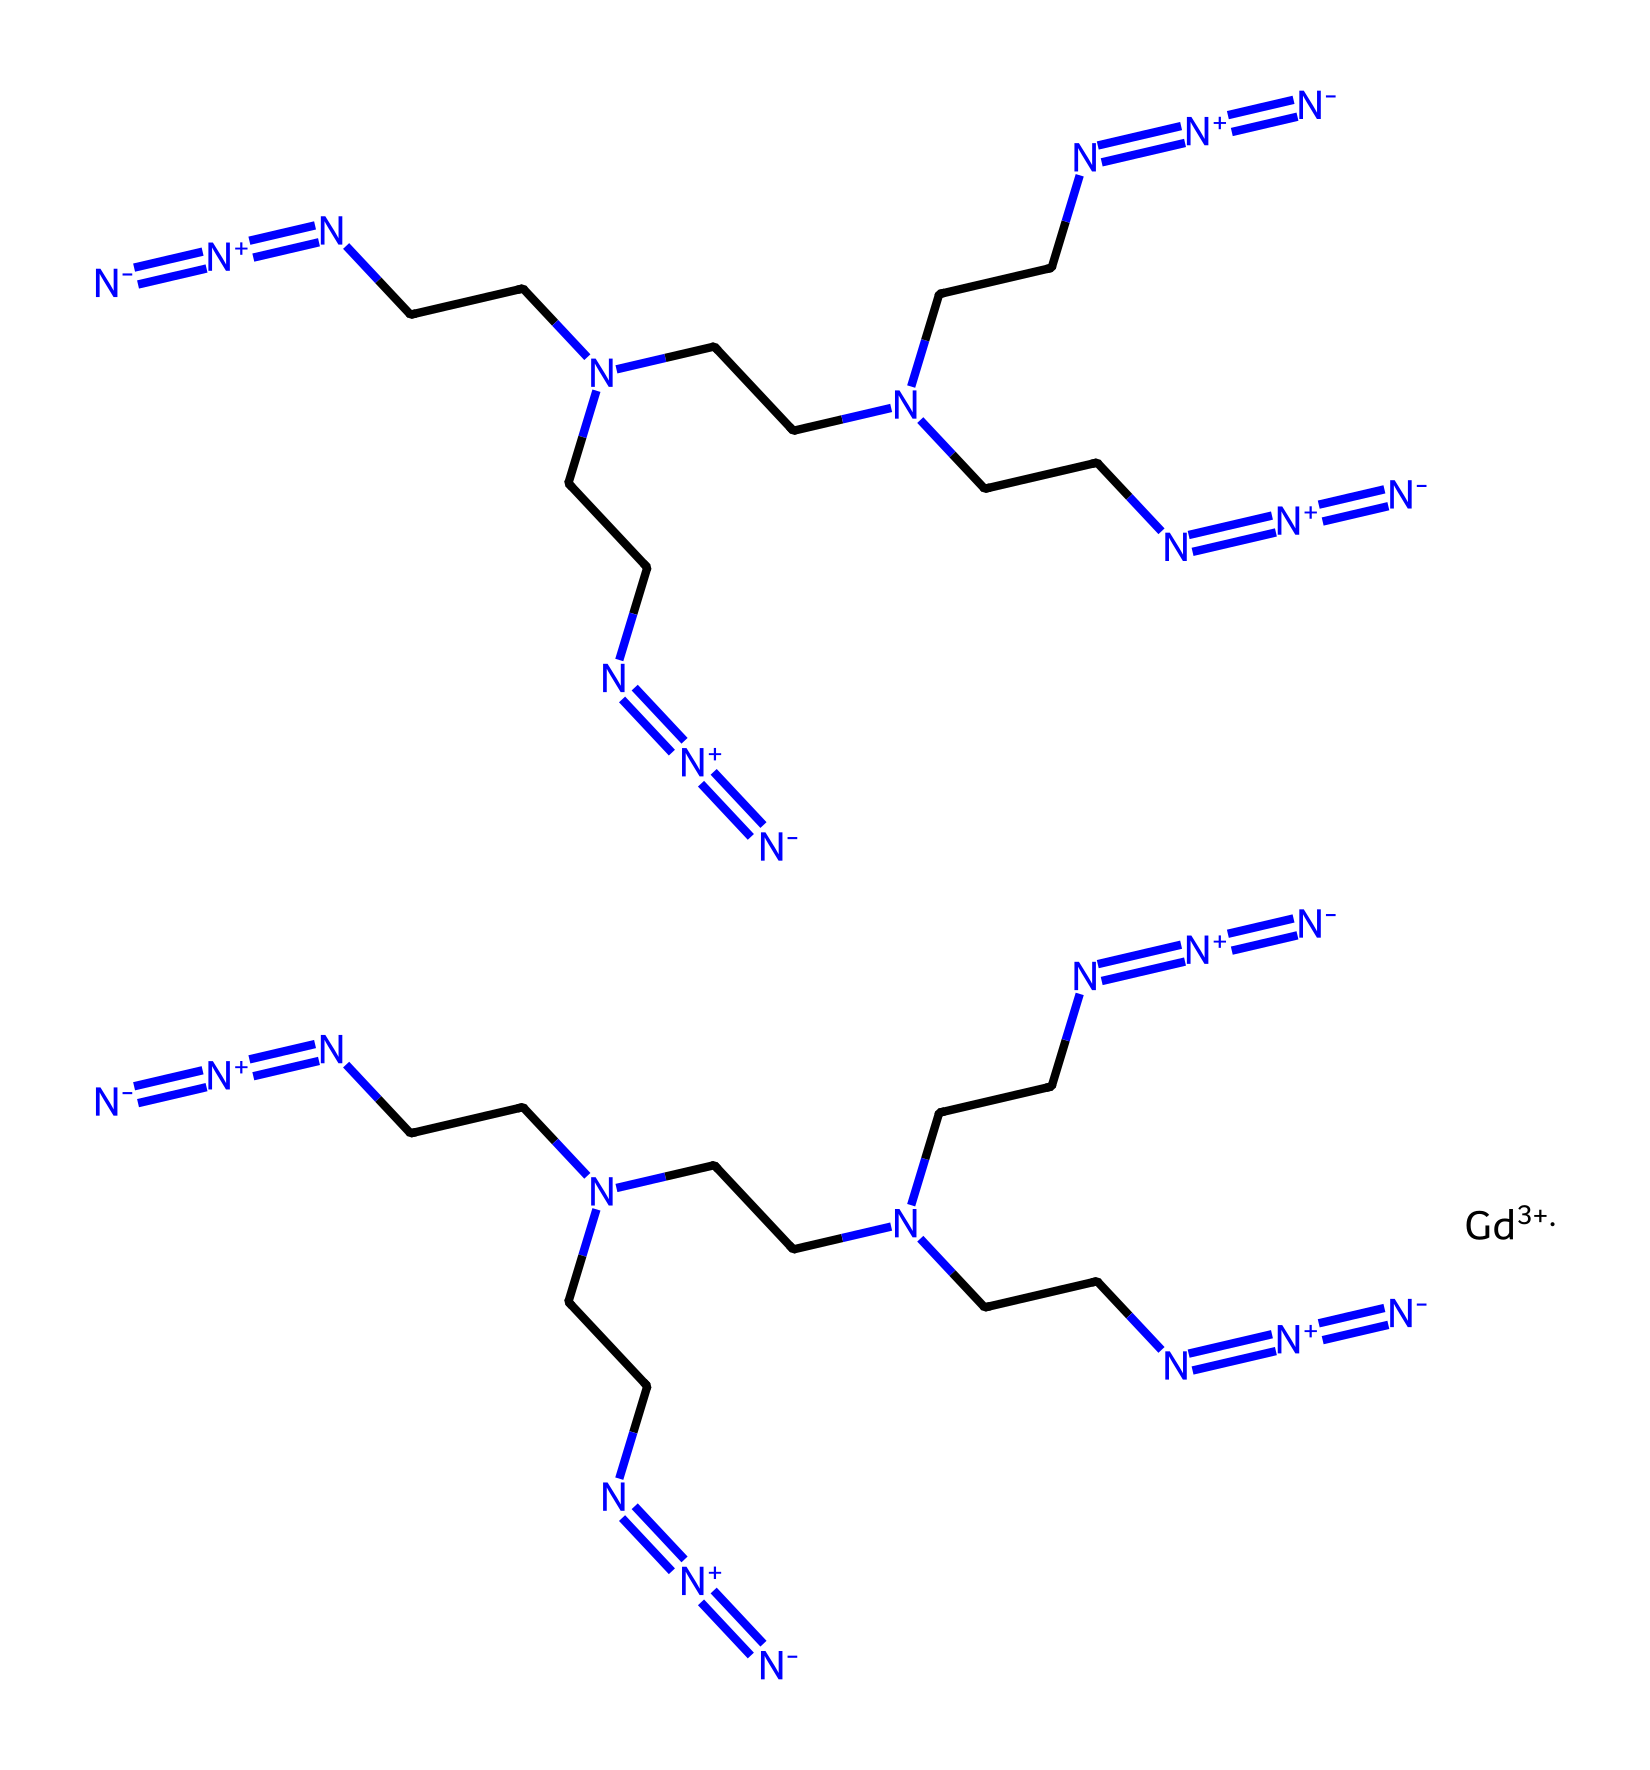What is the central metal ion in the structure? The chemical structure contains Gd, which represents gadolinium, a rare earth metal commonly used in contrast agents. Gadolinium is indicated by the notation "[Gd+3]", showing it is in the +3 oxidation state.
Answer: gadolinium How many azide groups are present in the molecule? The structure identifies azide groups by the "N#N" motif. Counting the occurrences reveals that there are 5 azide groups present within the structure, specifically each being part of various side chains attached to the central gadolinium.
Answer: five What is the primary function of gadolinium in this context? Gadolinium is primarily known for its use as a contrast agent in medical imaging due to its paramagnetic properties, which enhance the contrast in magnetic resonance imaging (MRI).
Answer: contrast agent Which part of this chemical structure contributes to its azide property? The repeating unit "N#N" directly indicates the presence of azide groups within the structure, which are characterized by three nitrogen atoms connected in a linear arrangement with a terminal nitrogen having a triple bond.
Answer: N#N What is the likely application of this azide-containing agent in rehabilitation assessment? Given its property as a contrast agent, this azide-containing structure is likely used for improving imaging clarity during reassessment of rehabilitation outcomes, allowing for better visualization of bodily structures.
Answer: imaging clarity 